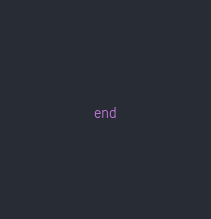Convert code to text. <code><loc_0><loc_0><loc_500><loc_500><_Ruby_>end
</code> 